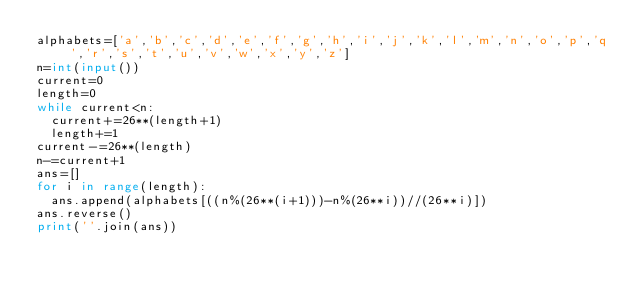Convert code to text. <code><loc_0><loc_0><loc_500><loc_500><_Python_>alphabets=['a','b','c','d','e','f','g','h','i','j','k','l','m','n','o','p','q','r','s','t','u','v','w','x','y','z']
n=int(input())
current=0
length=0
while current<n:
  current+=26**(length+1)
  length+=1
current-=26**(length)
n-=current+1
ans=[]
for i in range(length):
  ans.append(alphabets[((n%(26**(i+1)))-n%(26**i))//(26**i)])
ans.reverse()
print(''.join(ans))</code> 